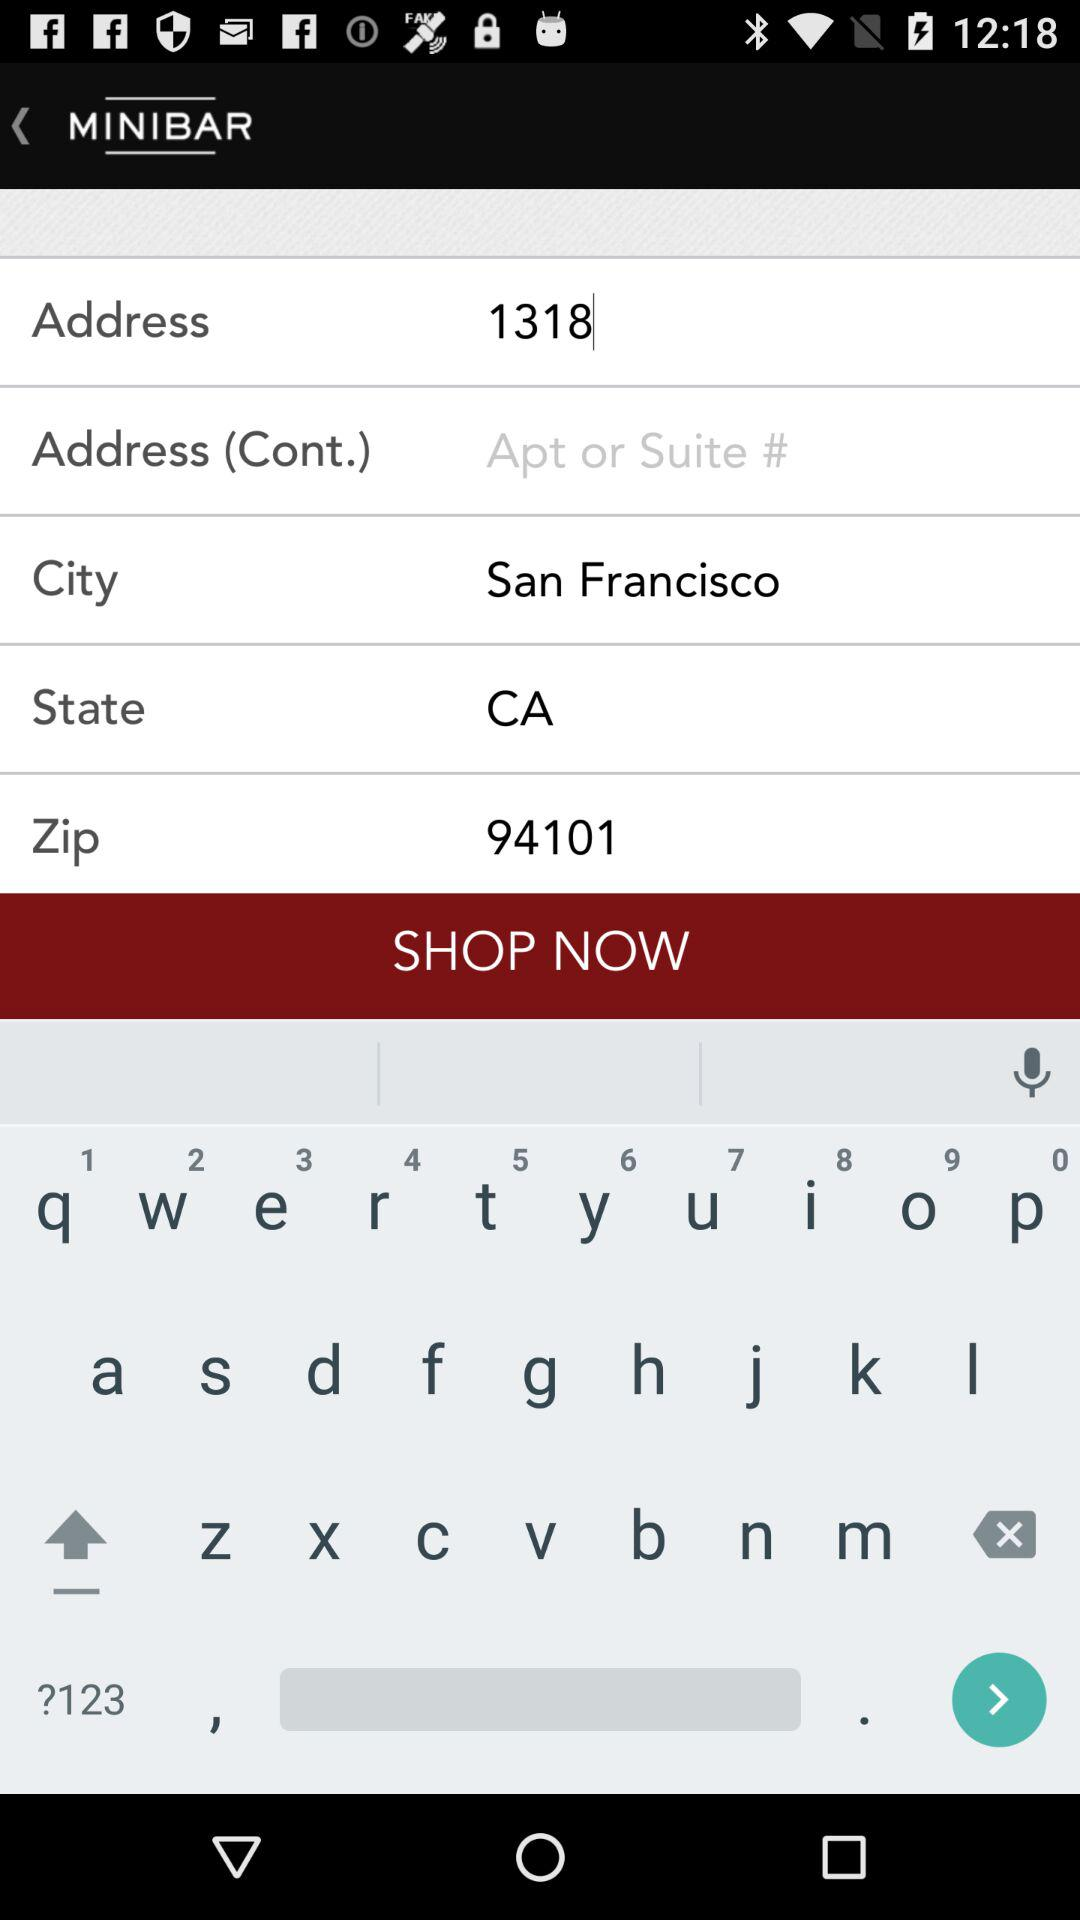What is the address? The address is 1318 San Francisco, CA 94101. 